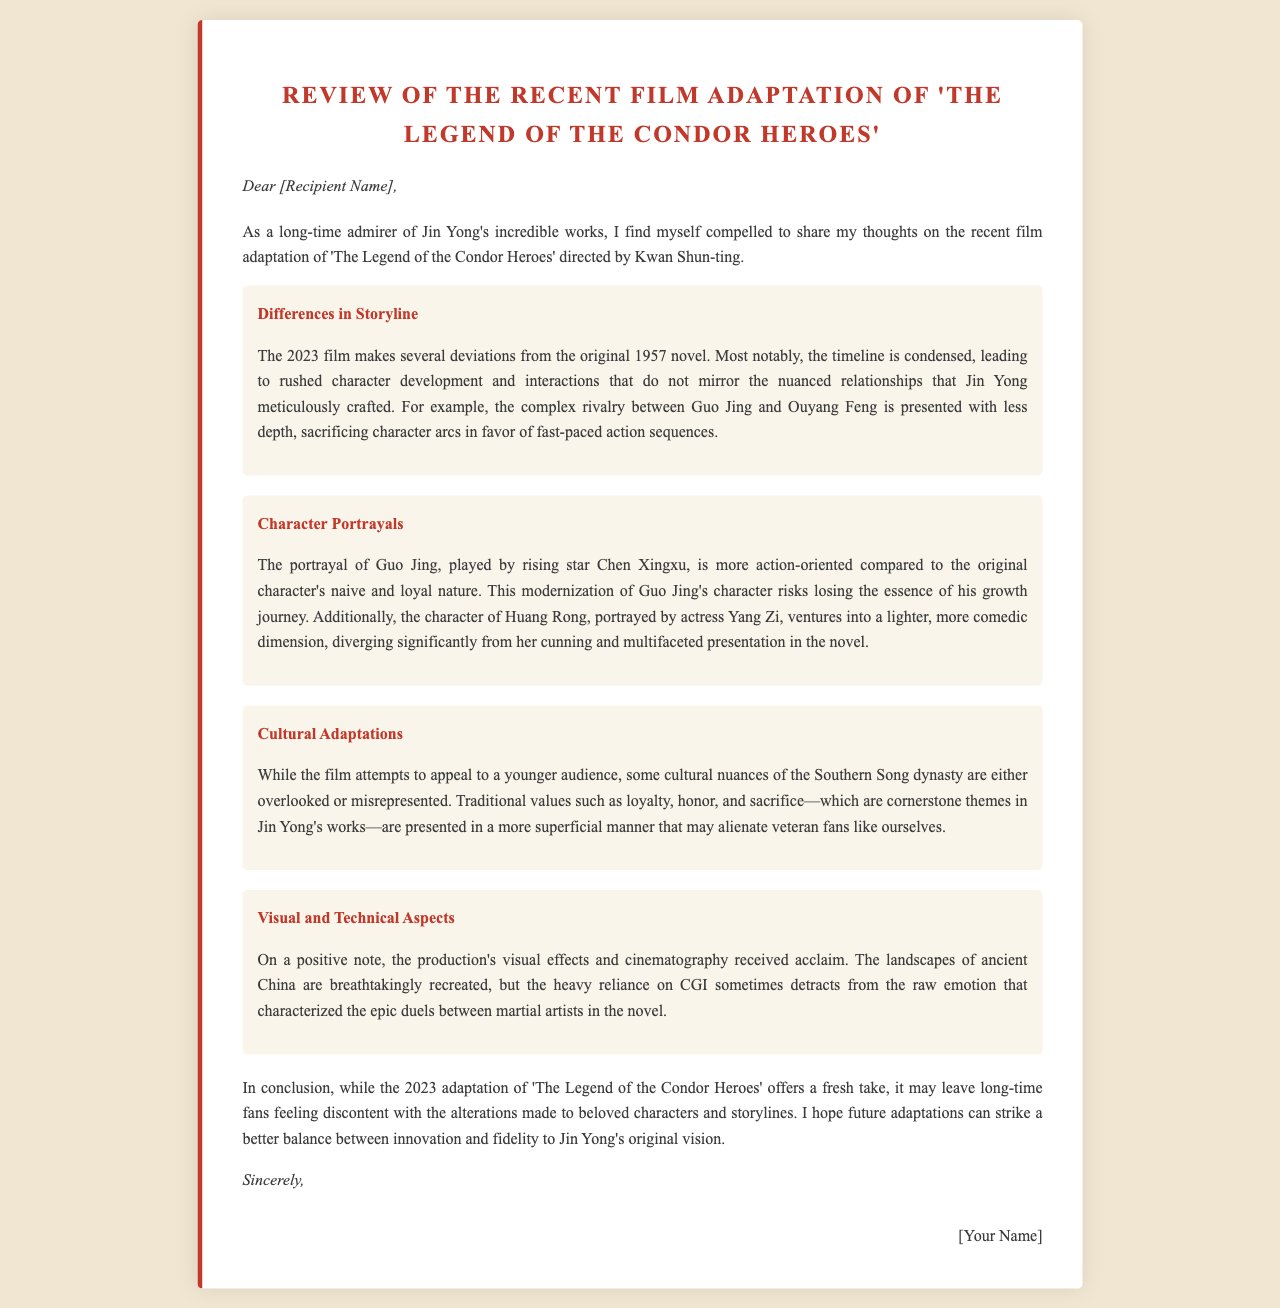What is the director's name of the adaptation? The document mentions that the recent film adaptation is directed by Kwan Shun-ting.
Answer: Kwan Shun-ting In what year was the original novel released? The document states that the original novel was published in 1957.
Answer: 1957 Who portrays Guo Jing in the film? The review identifies Chen Xingxu as the actor who plays Guo Jing.
Answer: Chen Xingxu What is one major difference highlighted regarding the character of Huang Rong? The review notes that Huang Rong ventures into a lighter, more comedic dimension in the film.
Answer: Lighter, more comedic dimension What aspect of the film received acclaim? The document mentions that the production's visual effects and cinematography were well-received.
Answer: Visual effects and cinematography What themes are described as being presented in a superficial manner? The document refers to themes of loyalty, honor, and sacrifice as being treated superficially in the adaptation.
Answer: Loyalty, honor, and sacrifice What does the author hope for future adaptations? The author expresses a hope for future adaptations to strike a better balance between innovation and fidelity.
Answer: Better balance between innovation and fidelity What is the general sentiment of the letter regarding the 2023 adaptation? The review concludes that the adaptation may leave long-time fans feeling discontent.
Answer: Discontent 